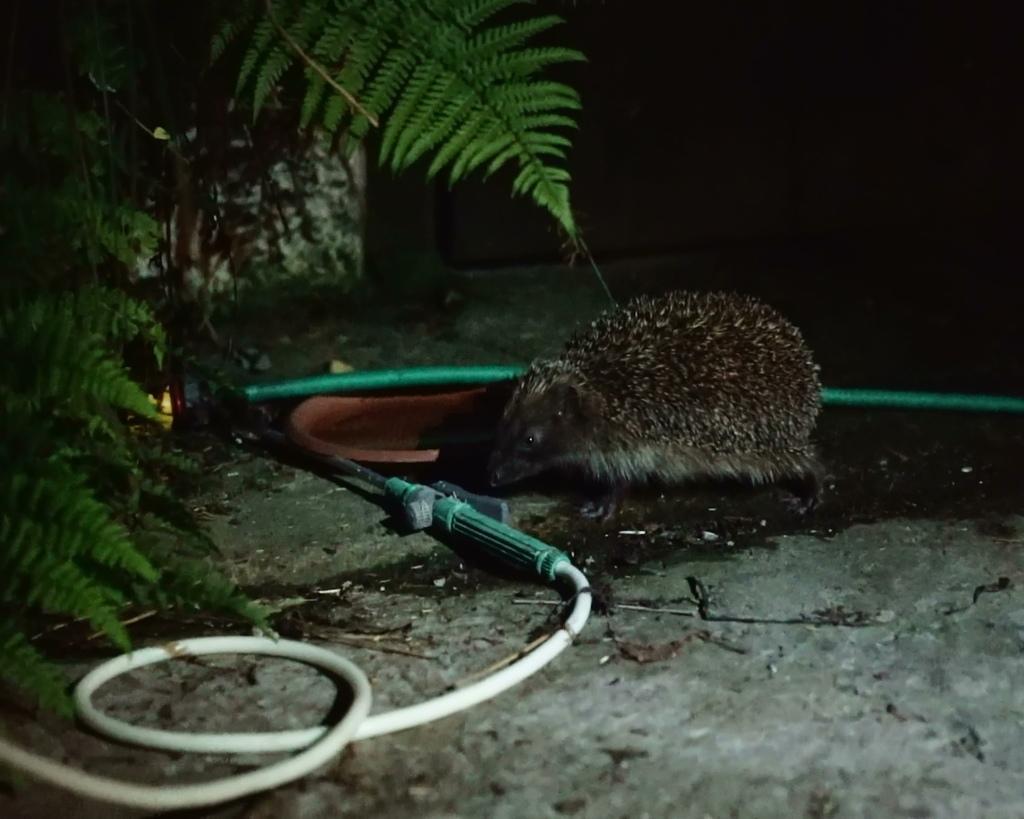Describe this image in one or two sentences. It is a rat in the middle of an image. On the left there are leaves of the tree. 